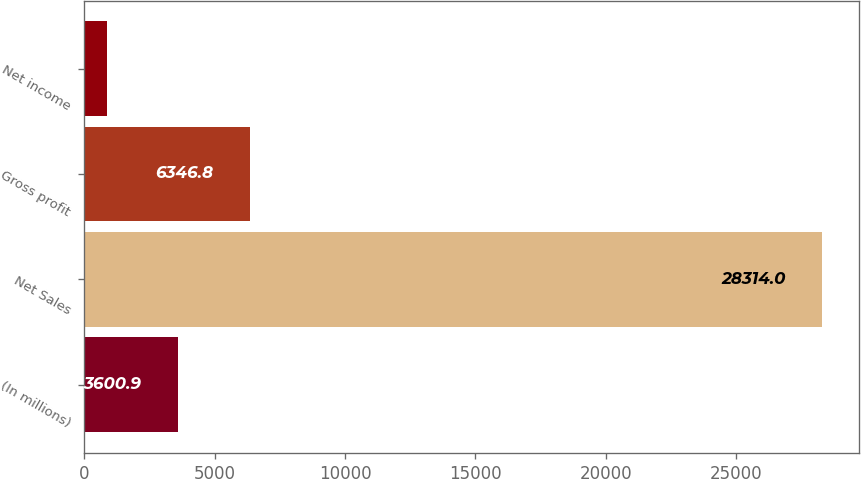Convert chart. <chart><loc_0><loc_0><loc_500><loc_500><bar_chart><fcel>(In millions)<fcel>Net Sales<fcel>Gross profit<fcel>Net income<nl><fcel>3600.9<fcel>28314<fcel>6346.8<fcel>855<nl></chart> 